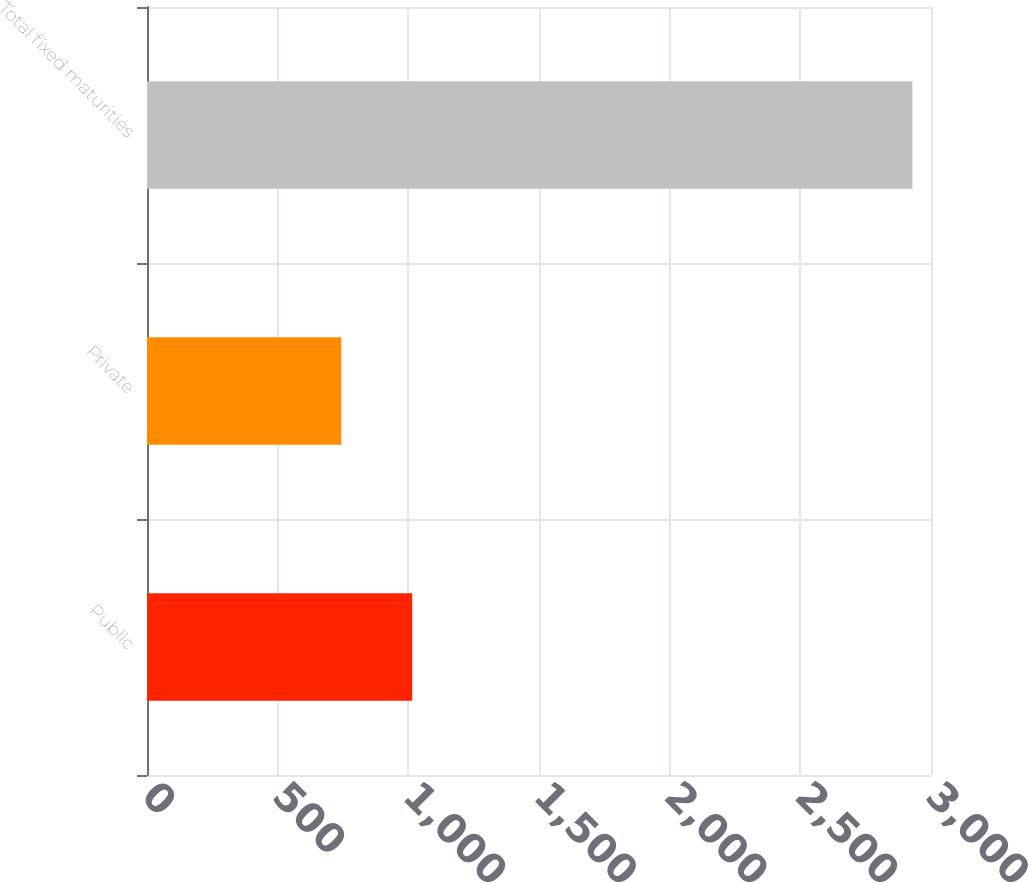<chart> <loc_0><loc_0><loc_500><loc_500><bar_chart><fcel>Public<fcel>Private<fcel>Total fixed maturities<nl><fcel>1015<fcel>743.2<fcel>2928.9<nl></chart> 